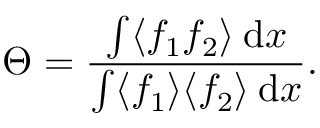Convert formula to latex. <formula><loc_0><loc_0><loc_500><loc_500>\Theta = \frac { \int \langle f _ { 1 } f _ { 2 } \rangle \, d x } { \int \langle f _ { 1 } \rangle \langle f _ { 2 } \rangle \, d x } .</formula> 